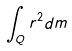Convert formula to latex. <formula><loc_0><loc_0><loc_500><loc_500>\int _ { Q } r ^ { 2 } d m</formula> 